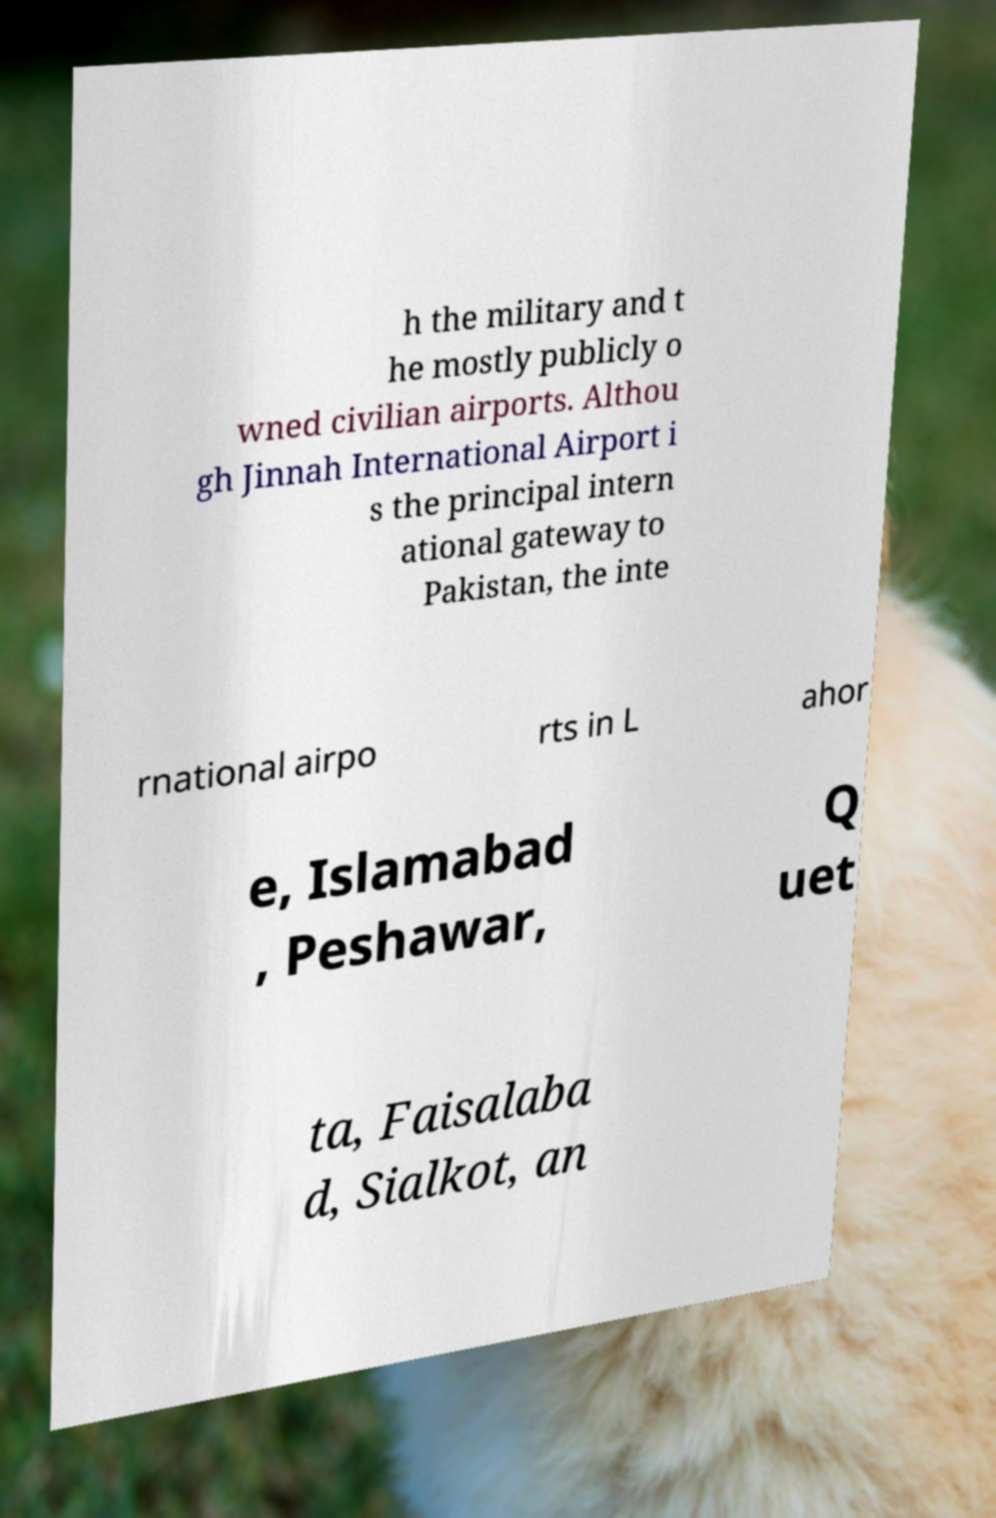Please read and relay the text visible in this image. What does it say? h the military and t he mostly publicly o wned civilian airports. Althou gh Jinnah International Airport i s the principal intern ational gateway to Pakistan, the inte rnational airpo rts in L ahor e, Islamabad , Peshawar, Q uet ta, Faisalaba d, Sialkot, an 